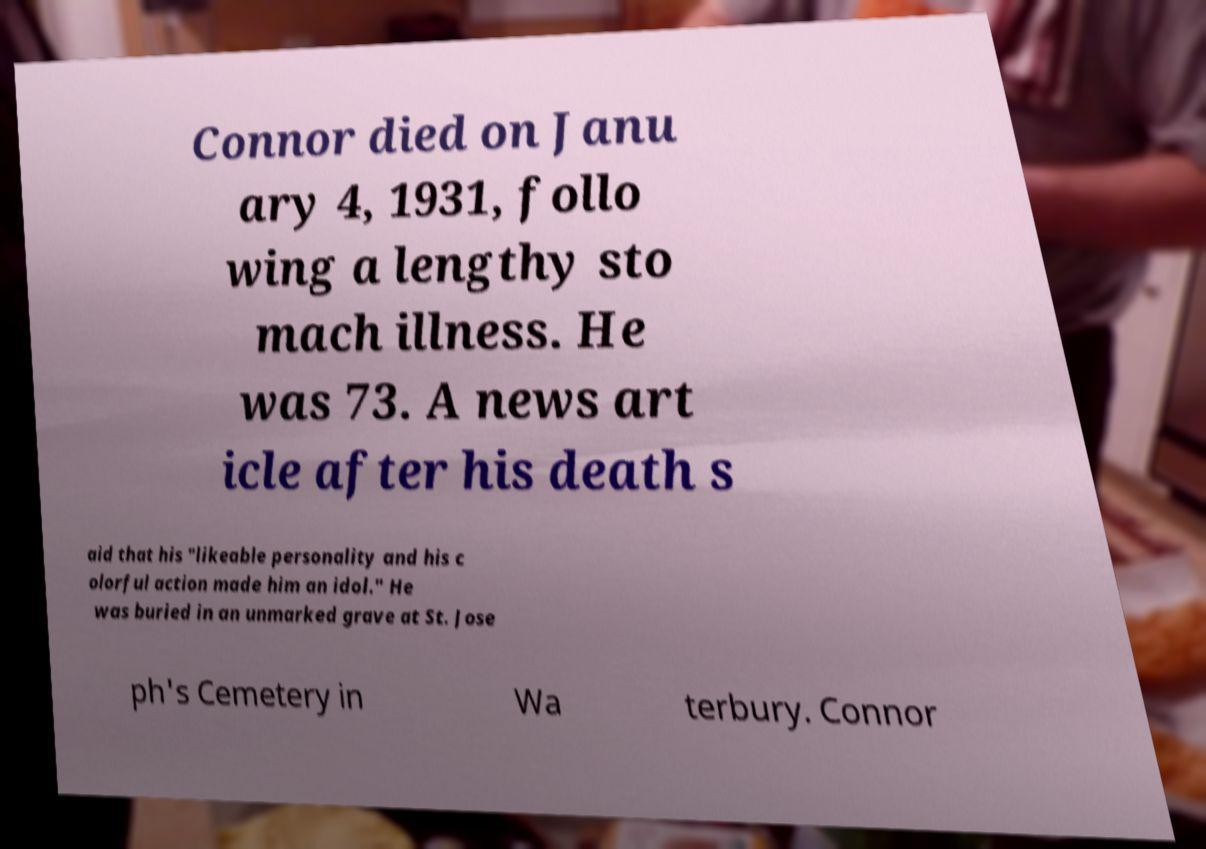Could you extract and type out the text from this image? Connor died on Janu ary 4, 1931, follo wing a lengthy sto mach illness. He was 73. A news art icle after his death s aid that his "likeable personality and his c olorful action made him an idol." He was buried in an unmarked grave at St. Jose ph's Cemetery in Wa terbury. Connor 